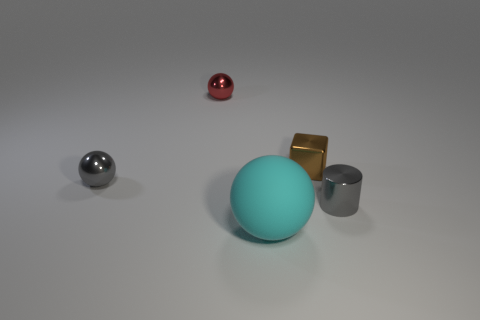Are there any other things that have the same size as the cyan object?
Give a very brief answer. No. What number of spheres are the same color as the tiny cylinder?
Provide a short and direct response. 1. What is the size of the metallic cube that is left of the tiny gray thing to the right of the tiny red metallic thing?
Make the answer very short. Small. Are there any big brown spheres that have the same material as the cyan object?
Give a very brief answer. No. Does the small metal sphere left of the tiny red metal object have the same color as the tiny metallic object that is on the right side of the brown object?
Give a very brief answer. Yes. There is a small gray metal thing left of the red ball; is there a small red thing behind it?
Ensure brevity in your answer.  Yes. Does the tiny gray metallic object that is on the left side of the tiny gray metal cylinder have the same shape as the cyan matte thing in front of the metallic cube?
Keep it short and to the point. Yes. Are the small gray object that is to the right of the large rubber ball and the object that is behind the tiny brown shiny block made of the same material?
Your answer should be very brief. Yes. What material is the red thing behind the tiny gray object on the left side of the cyan rubber ball?
Give a very brief answer. Metal. What is the shape of the small gray thing that is on the left side of the gray thing that is in front of the metallic sphere in front of the tiny red shiny ball?
Offer a terse response. Sphere. 